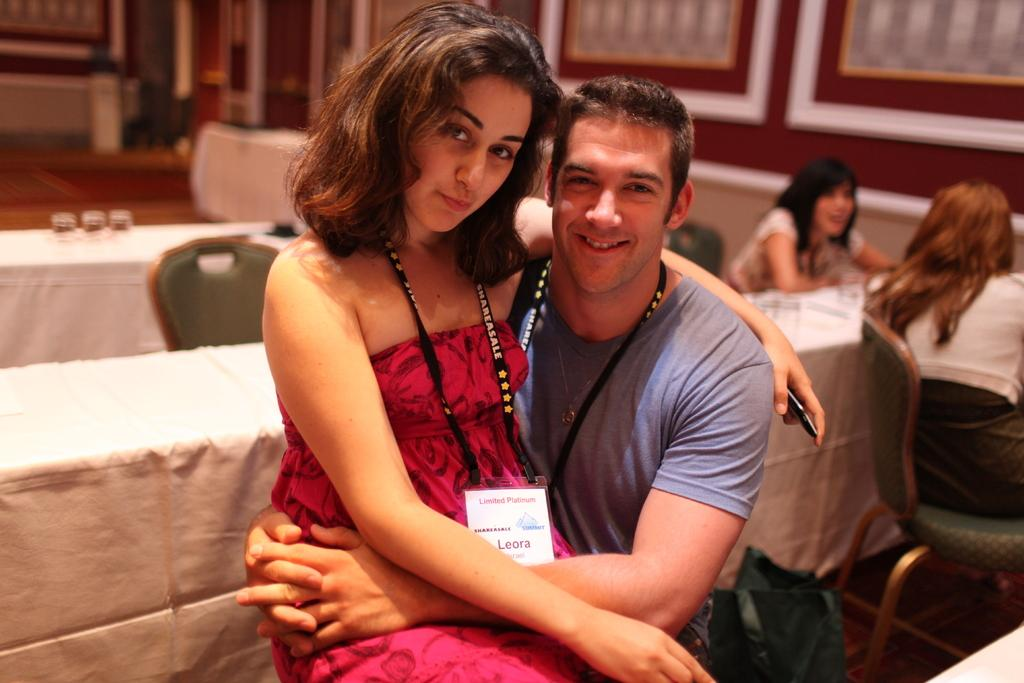Who are the two people in the center of the image? There is a man and a woman sitting in the center of the image. What can be seen in the background of the image? There are chairs, tables, glasses, persons, a door, and a wall in the background of the image. What might the people in the background be doing? It is not clear from the image what the people in the background are doing. What is the purpose of the door in the background? The purpose of the door in the background is to provide access to another room or area. 